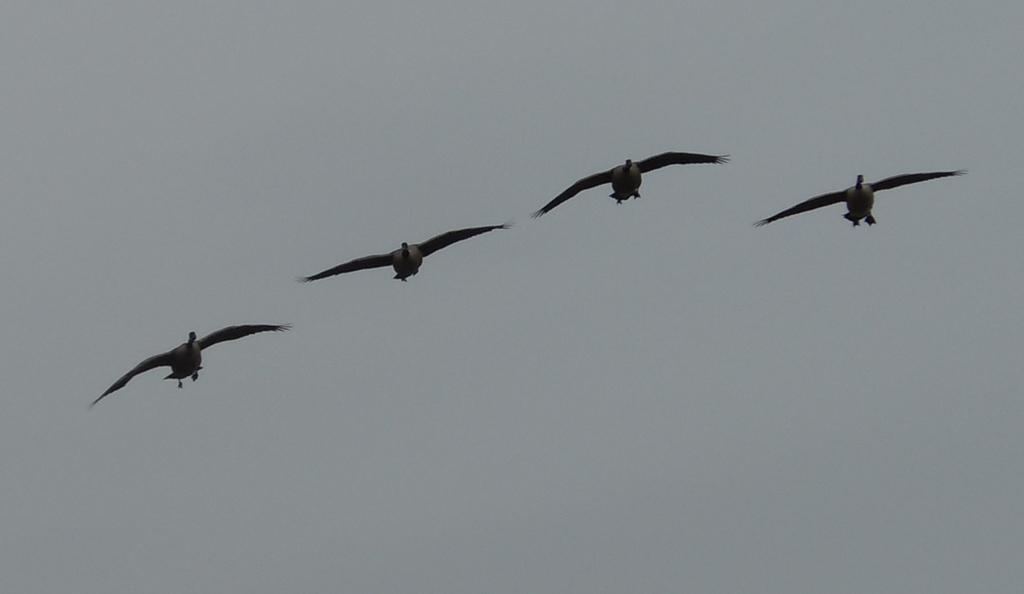How many birds are visible in the image? There are four birds in the image. What are the birds doing in the image? The birds are flying in the air. What type of twist can be seen in the image? There is no twist present in the image; it features four birds flying in the air. How many babies are visible in the image? There are no babies present in the image; it features four birds flying in the air. 